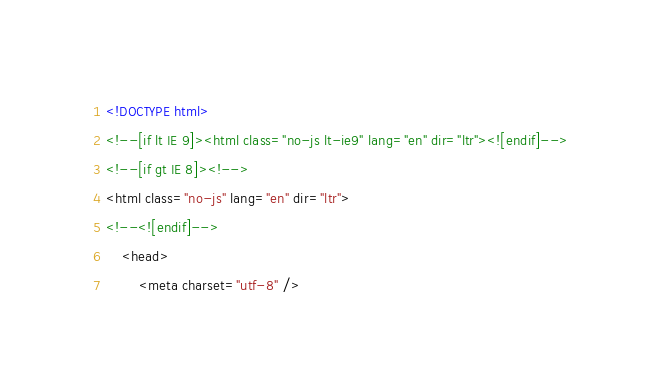<code> <loc_0><loc_0><loc_500><loc_500><_HTML_><!DOCTYPE html>
<!--[if lt IE 9]><html class="no-js lt-ie9" lang="en" dir="ltr"><![endif]-->
<!--[if gt IE 8]><!-->
<html class="no-js" lang="en" dir="ltr">
<!--<![endif]-->
	<head>
		<meta charset="utf-8" /></code> 